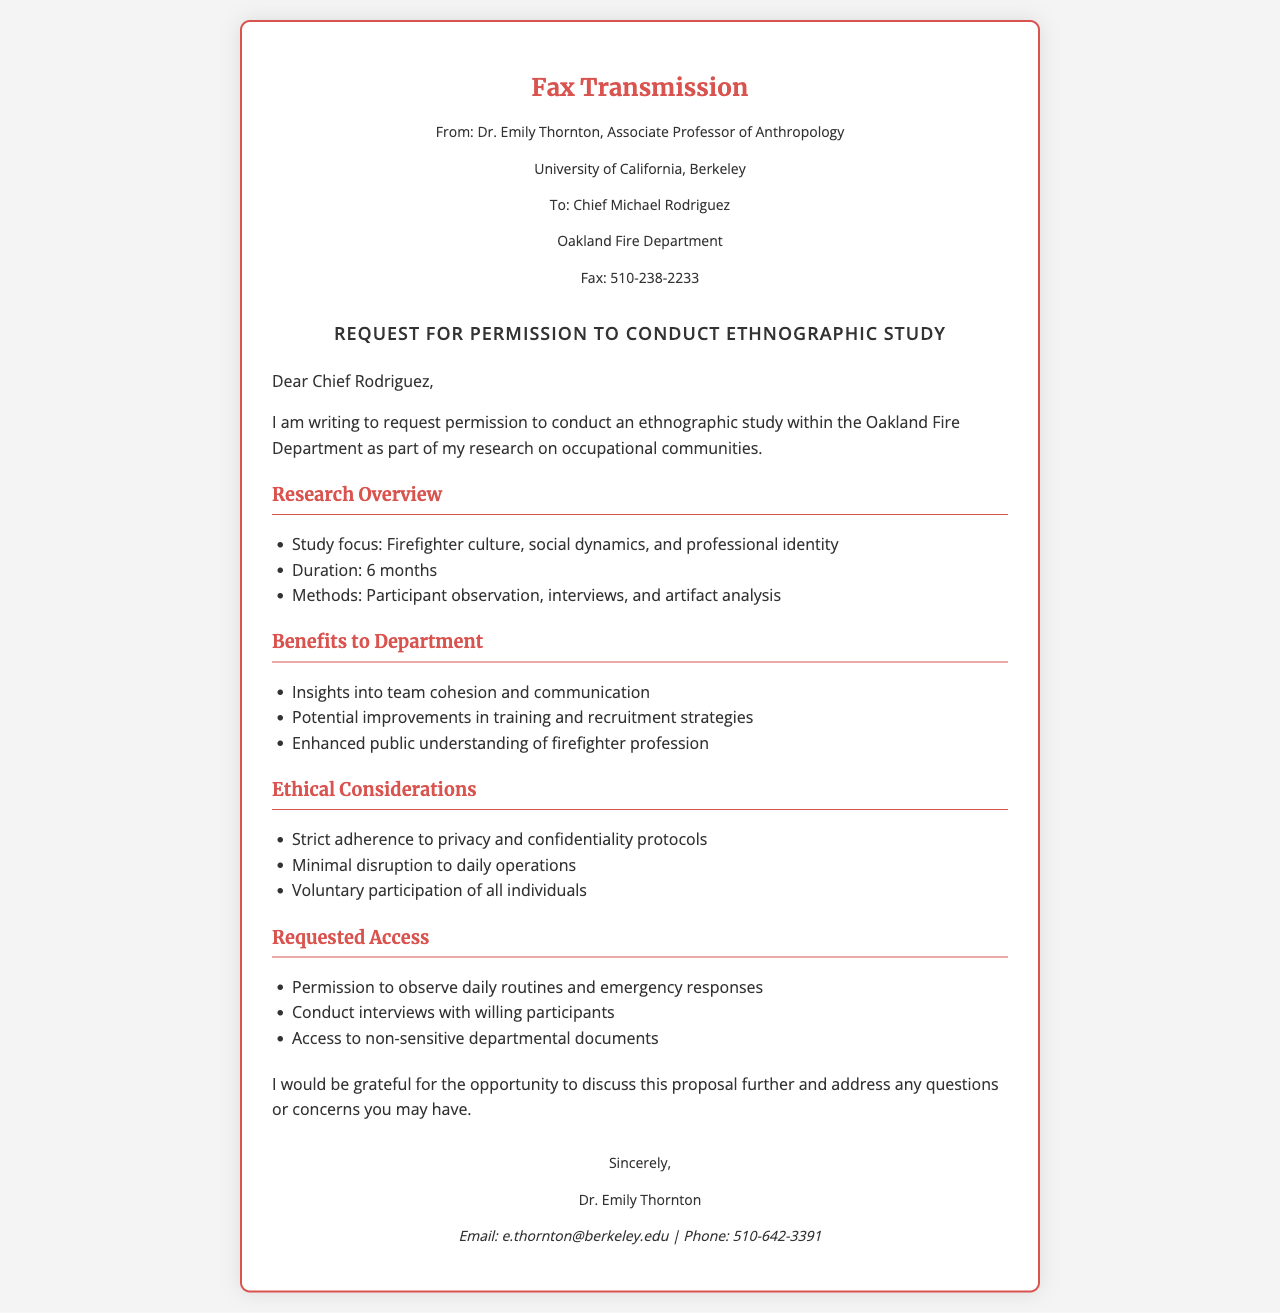What is the name of the sender? The sender's name is specified in the document, which is Dr. Emily Thornton.
Answer: Dr. Emily Thornton Who is the recipient of the fax? The recipient's name is mentioned in the document as Chief Michael Rodriguez.
Answer: Chief Michael Rodriguez What is the duration of the study? The duration of the study is stated in the document as 6 months.
Answer: 6 months What is the study focus? The document lists the study focus, which is on firefighter culture, social dynamics, and professional identity.
Answer: Firefighter culture, social dynamics, and professional identity What ethical consideration is highlighted? The document mentions the need for strict adherence to privacy and confidentiality protocols as an ethical consideration.
Answer: Privacy and confidentiality protocols What type of methods will be used for the study? The methods section specifies participant observation, interviews, and artifact analysis as the approaches for the study.
Answer: Participant observation, interviews, and artifact analysis What are the requested access permissions? The document outlines that permission is requested to observe daily routines and emergency responses, conduct interviews, and access non-sensitive documents.
Answer: Observe daily routines and emergency responses, conduct interviews, access non-sensitive documents What is the main purpose of the request? The main purpose of the request is to gain permission to conduct an ethnographic study within the Oakland Fire Department.
Answer: Conduct an ethnographic study What is the email address of the sender? The document provides the sender's email address for contact, which is e.thornton@berkeley.edu.
Answer: e.thornton@berkeley.edu 